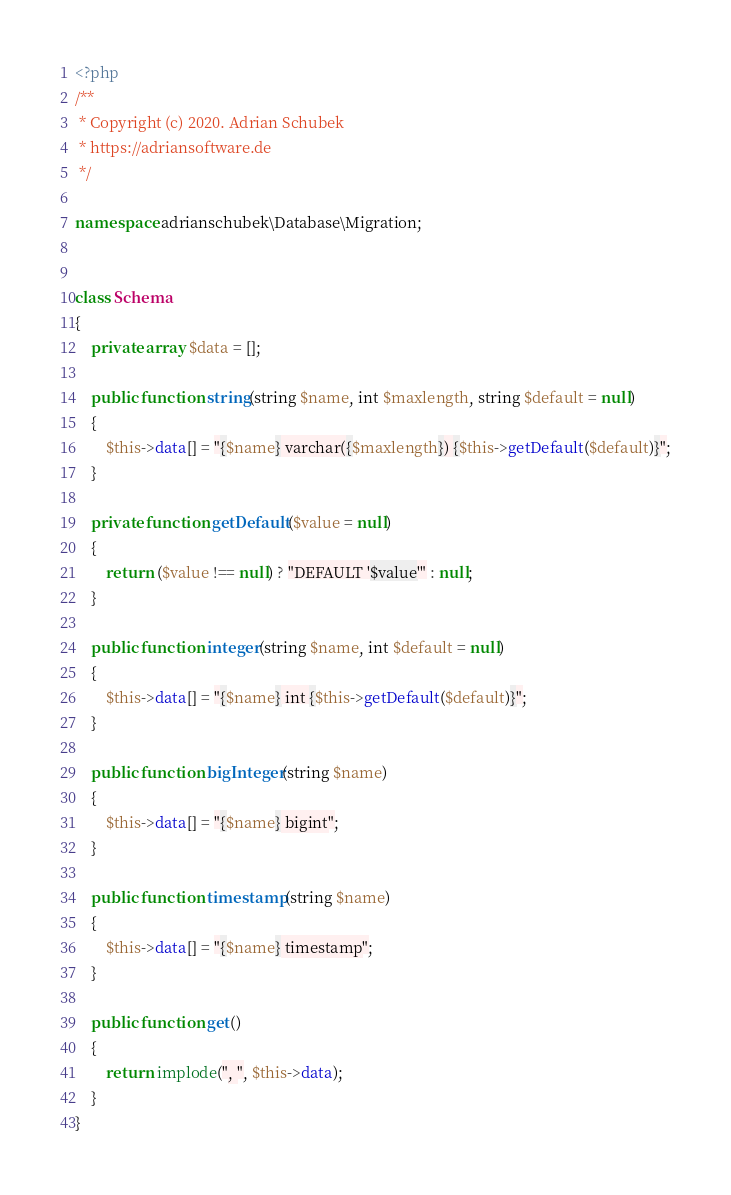Convert code to text. <code><loc_0><loc_0><loc_500><loc_500><_PHP_><?php
/**
 * Copyright (c) 2020. Adrian Schubek
 * https://adriansoftware.de
 */

namespace adrianschubek\Database\Migration;


class Schema
{
    private array $data = [];

    public function string(string $name, int $maxlength, string $default = null)
    {
        $this->data[] = "{$name} varchar({$maxlength}) {$this->getDefault($default)}";
    }

    private function getDefault($value = null)
    {
        return ($value !== null) ? "DEFAULT '$value'" : null;
    }

    public function integer(string $name, int $default = null)
    {
        $this->data[] = "{$name} int {$this->getDefault($default)}";
    }

    public function bigInteger(string $name)
    {
        $this->data[] = "{$name} bigint";
    }

    public function timestamp(string $name)
    {
        $this->data[] = "{$name} timestamp";
    }

    public function get()
    {
        return implode(", ", $this->data);
    }
}</code> 